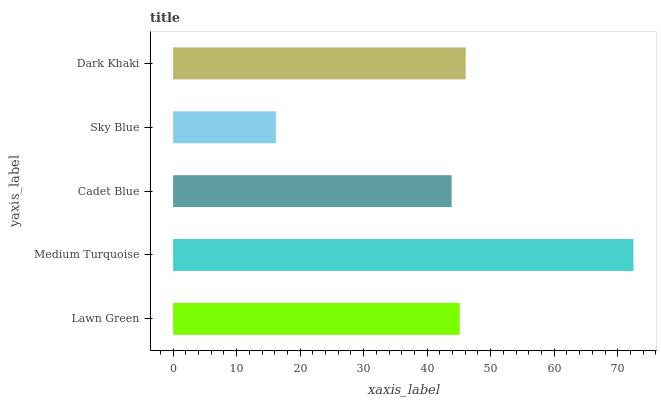Is Sky Blue the minimum?
Answer yes or no. Yes. Is Medium Turquoise the maximum?
Answer yes or no. Yes. Is Cadet Blue the minimum?
Answer yes or no. No. Is Cadet Blue the maximum?
Answer yes or no. No. Is Medium Turquoise greater than Cadet Blue?
Answer yes or no. Yes. Is Cadet Blue less than Medium Turquoise?
Answer yes or no. Yes. Is Cadet Blue greater than Medium Turquoise?
Answer yes or no. No. Is Medium Turquoise less than Cadet Blue?
Answer yes or no. No. Is Lawn Green the high median?
Answer yes or no. Yes. Is Lawn Green the low median?
Answer yes or no. Yes. Is Sky Blue the high median?
Answer yes or no. No. Is Cadet Blue the low median?
Answer yes or no. No. 